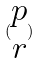Convert formula to latex. <formula><loc_0><loc_0><loc_500><loc_500>( \begin{matrix} p \\ r \end{matrix} )</formula> 